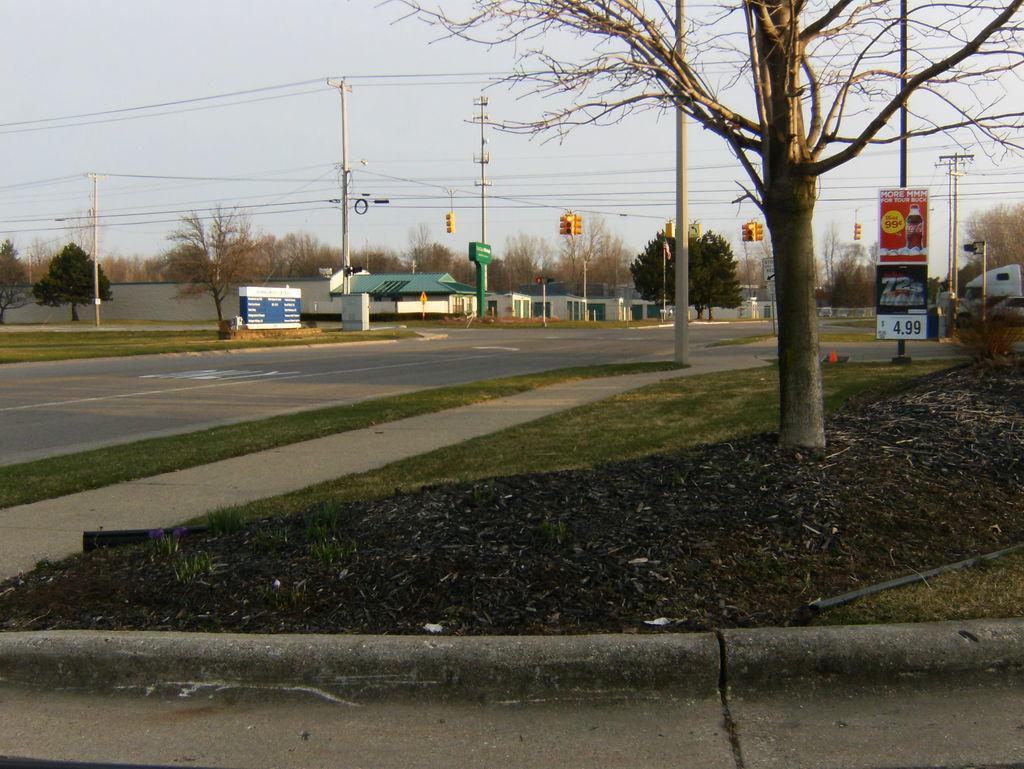Please provide a concise description of this image. In this image we can see the trees and also houses and electrical poles with wires. We can also see the hoarding to the pole in this image. Roads are also visible in this image. At the top there is sky. 